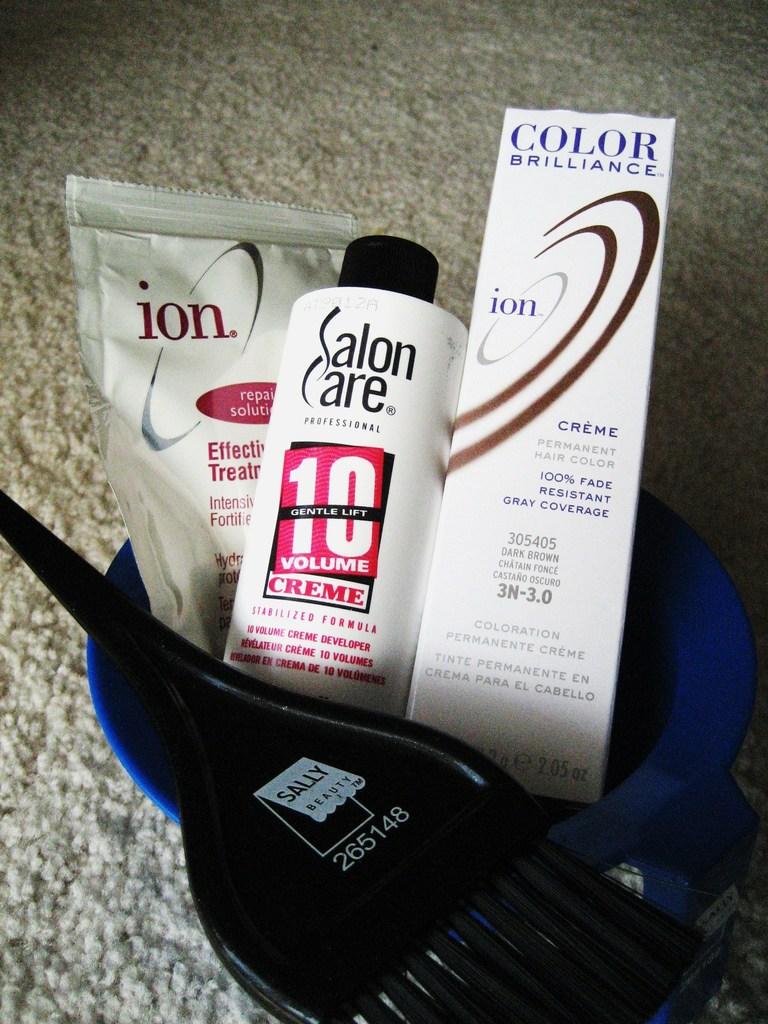What color is this hair dye?
Make the answer very short. Dark brown. What six digits can we see on the black object?
Keep it short and to the point. 265148. 